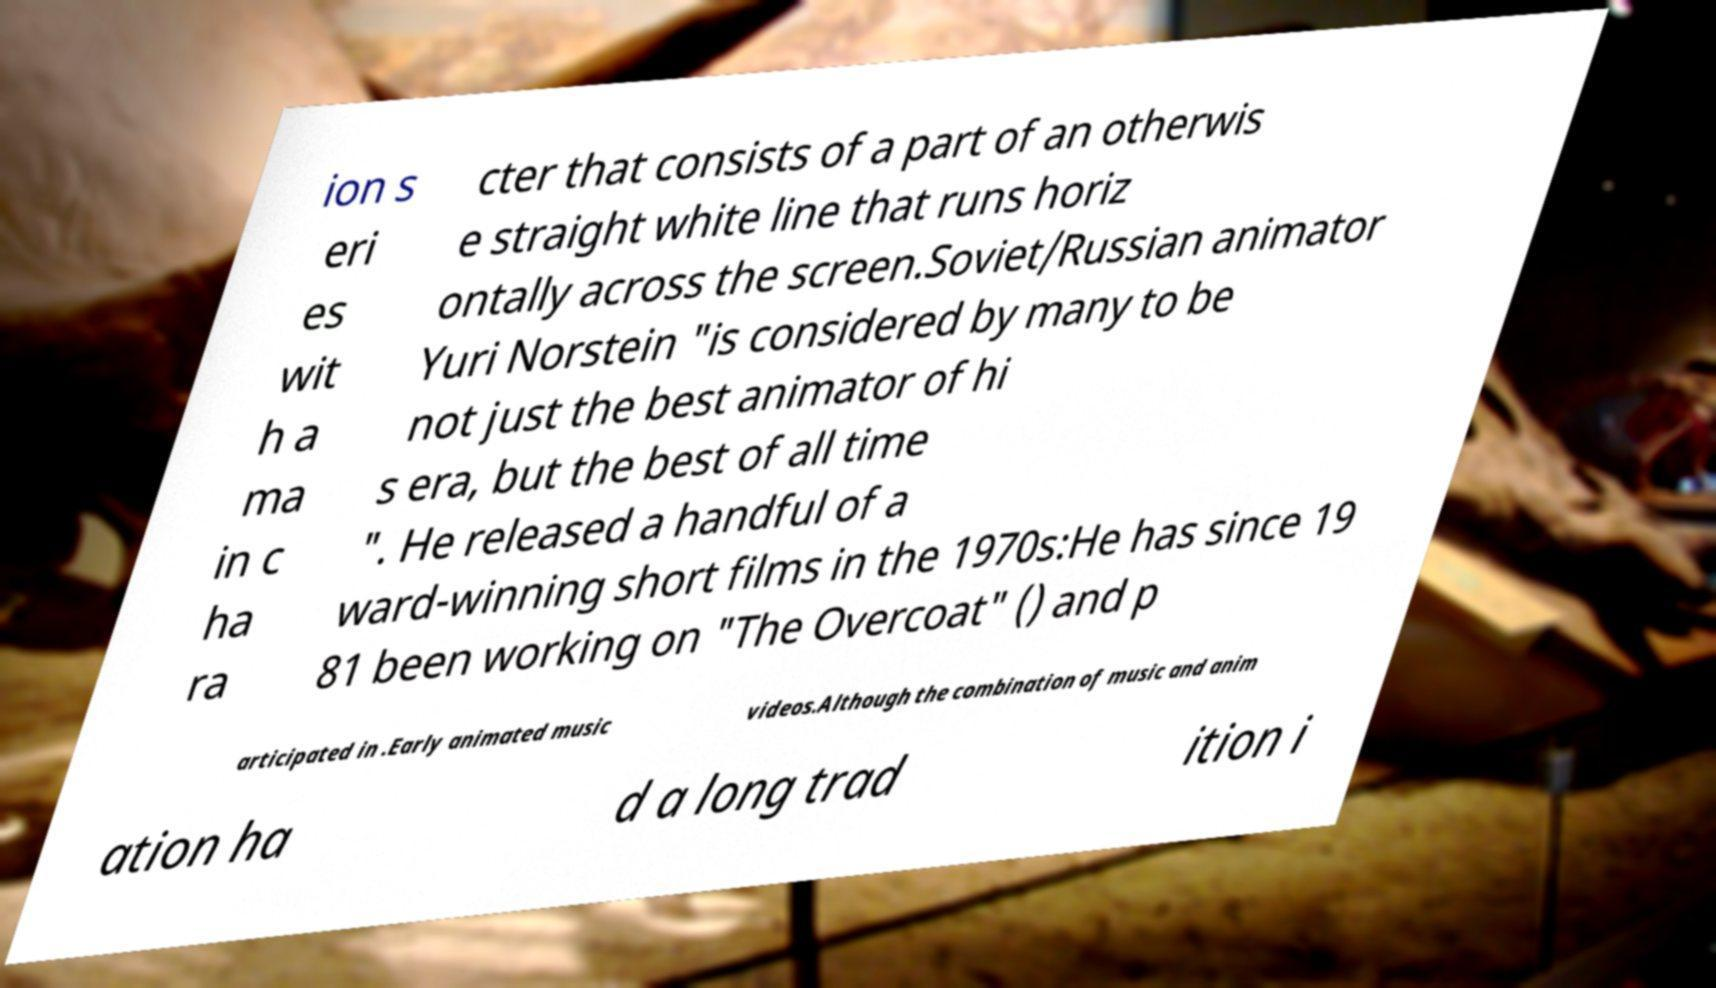For documentation purposes, I need the text within this image transcribed. Could you provide that? ion s eri es wit h a ma in c ha ra cter that consists of a part of an otherwis e straight white line that runs horiz ontally across the screen.Soviet/Russian animator Yuri Norstein "is considered by many to be not just the best animator of hi s era, but the best of all time ". He released a handful of a ward-winning short films in the 1970s:He has since 19 81 been working on "The Overcoat" () and p articipated in .Early animated music videos.Although the combination of music and anim ation ha d a long trad ition i 